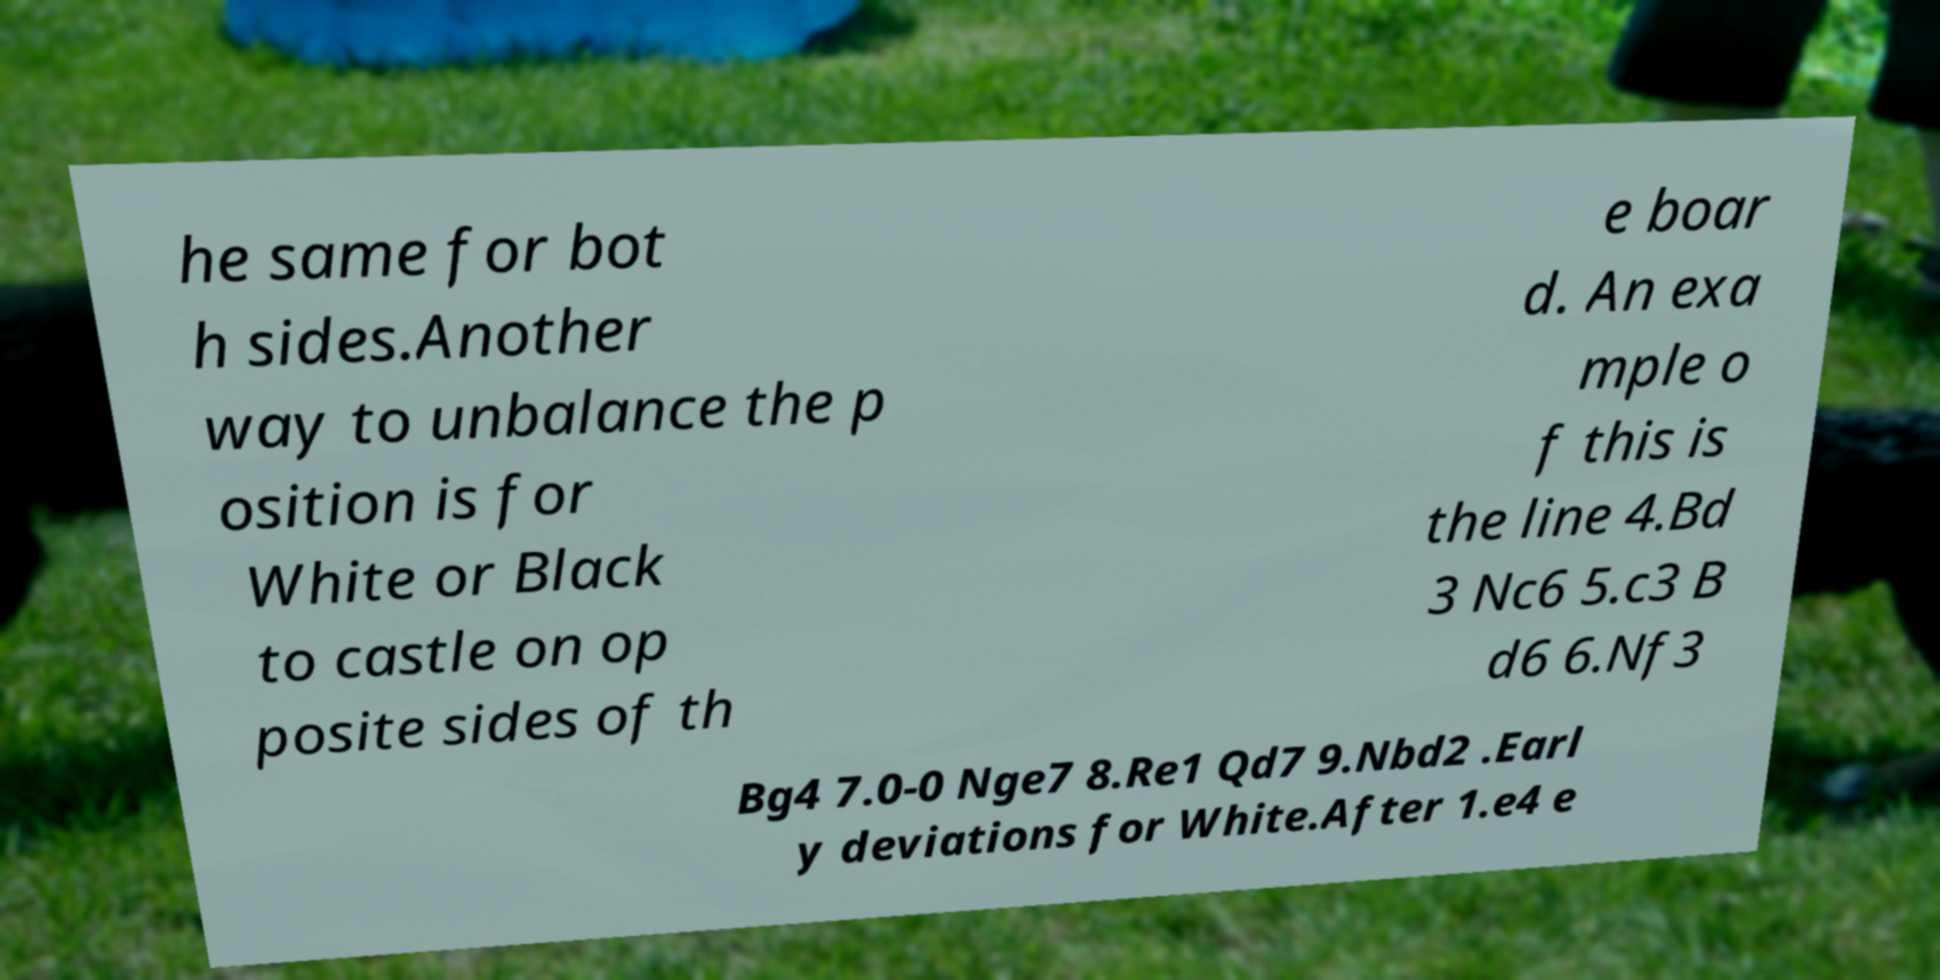Could you extract and type out the text from this image? he same for bot h sides.Another way to unbalance the p osition is for White or Black to castle on op posite sides of th e boar d. An exa mple o f this is the line 4.Bd 3 Nc6 5.c3 B d6 6.Nf3 Bg4 7.0-0 Nge7 8.Re1 Qd7 9.Nbd2 .Earl y deviations for White.After 1.e4 e 